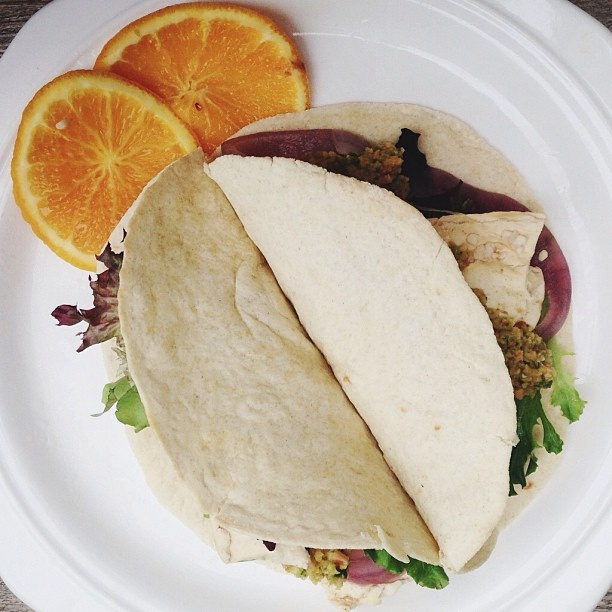Describe the objects in this image and their specific colors. I can see sandwich in black, lightgray, and tan tones, sandwich in black and tan tones, orange in black, red, orange, and tan tones, and orange in black, red, orange, and tan tones in this image. 